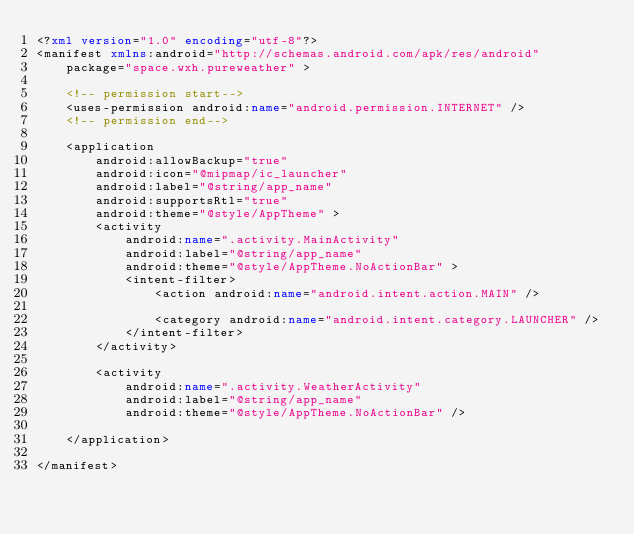<code> <loc_0><loc_0><loc_500><loc_500><_XML_><?xml version="1.0" encoding="utf-8"?>
<manifest xmlns:android="http://schemas.android.com/apk/res/android"
    package="space.wxh.pureweather" >

    <!-- permission start-->
    <uses-permission android:name="android.permission.INTERNET" />
    <!-- permission end-->

    <application
        android:allowBackup="true"
        android:icon="@mipmap/ic_launcher"
        android:label="@string/app_name"
        android:supportsRtl="true"
        android:theme="@style/AppTheme" >
        <activity
            android:name=".activity.MainActivity"
            android:label="@string/app_name"
            android:theme="@style/AppTheme.NoActionBar" >
            <intent-filter>
                <action android:name="android.intent.action.MAIN" />

                <category android:name="android.intent.category.LAUNCHER" />
            </intent-filter>
        </activity>

        <activity
            android:name=".activity.WeatherActivity"
            android:label="@string/app_name"
            android:theme="@style/AppTheme.NoActionBar" />

    </application>

</manifest>
</code> 